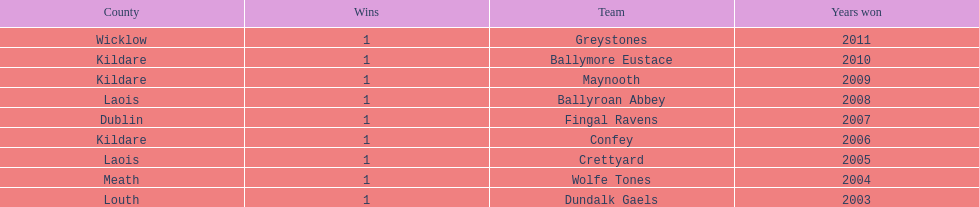How many wins does greystones have? 1. 